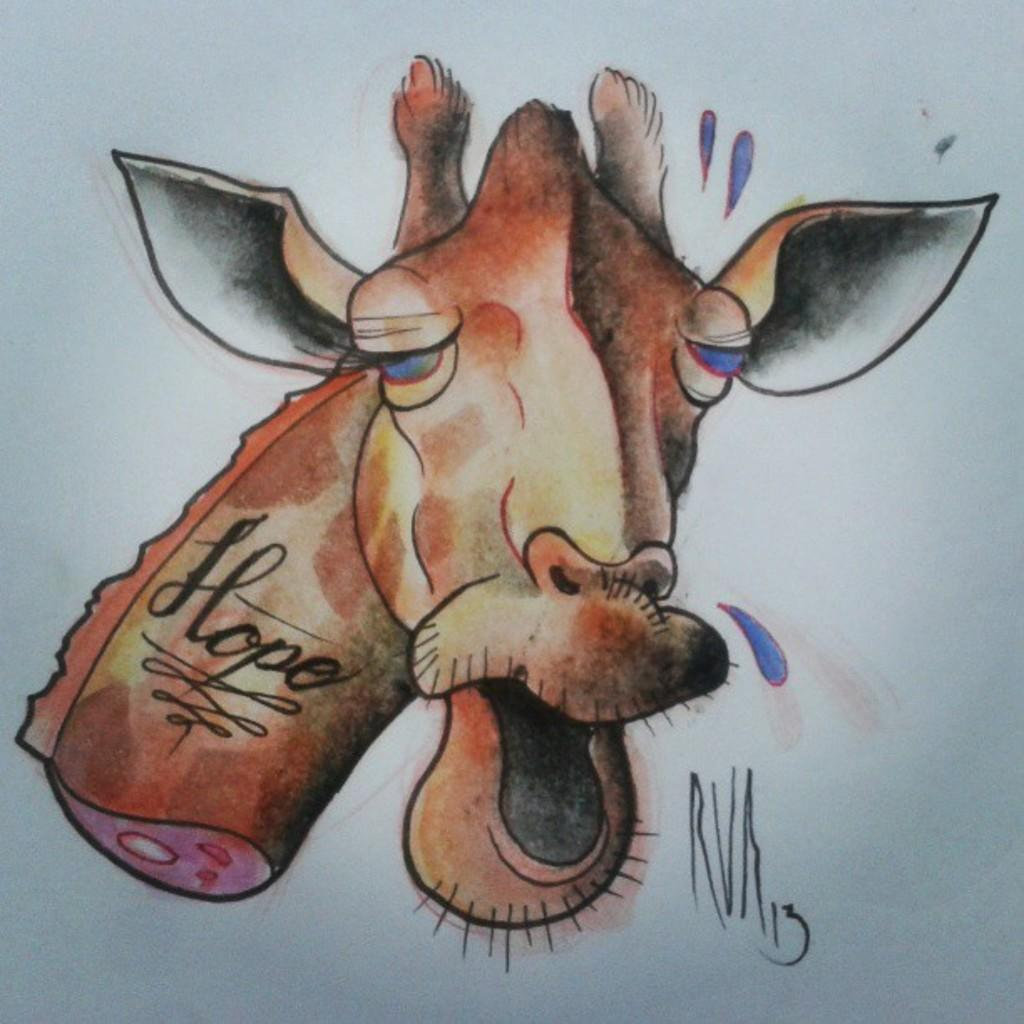What is depicted on the paper in the image? There is a sketch of a giraffe on the paper. What color is the background of the sketch? The background of the sketch is white. What color is the giraffe in the sketch? The giraffe in the sketch is brown. What type of crack is visible on the coach in the image? There is no coach or crack present in the image; it features a sketch of a giraffe on paper. 